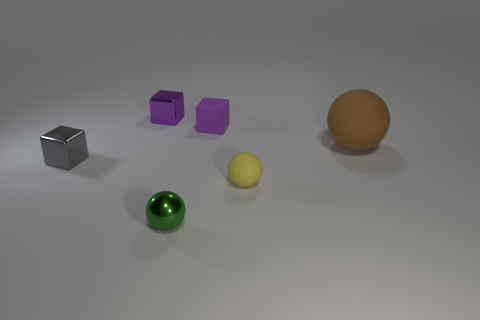Do the matte block and the big sphere have the same color?
Keep it short and to the point. No. There is a metal object that is the same color as the small rubber block; what shape is it?
Your response must be concise. Cube. There is a small purple thing that is left of the green shiny sphere; how many cubes are on the right side of it?
Offer a very short reply. 1. What number of brown spheres are made of the same material as the yellow ball?
Give a very brief answer. 1. There is a brown sphere; are there any brown rubber objects left of it?
Provide a succinct answer. No. The metallic sphere that is the same size as the matte cube is what color?
Your answer should be compact. Green. How many objects are either small things that are behind the small green metal object or purple metal things?
Your answer should be compact. 4. There is a matte thing that is behind the gray metallic cube and in front of the small purple matte object; what size is it?
Your answer should be compact. Large. What is the size of the thing that is the same color as the small matte cube?
Offer a terse response. Small. How many other objects are there of the same size as the yellow object?
Keep it short and to the point. 4. 